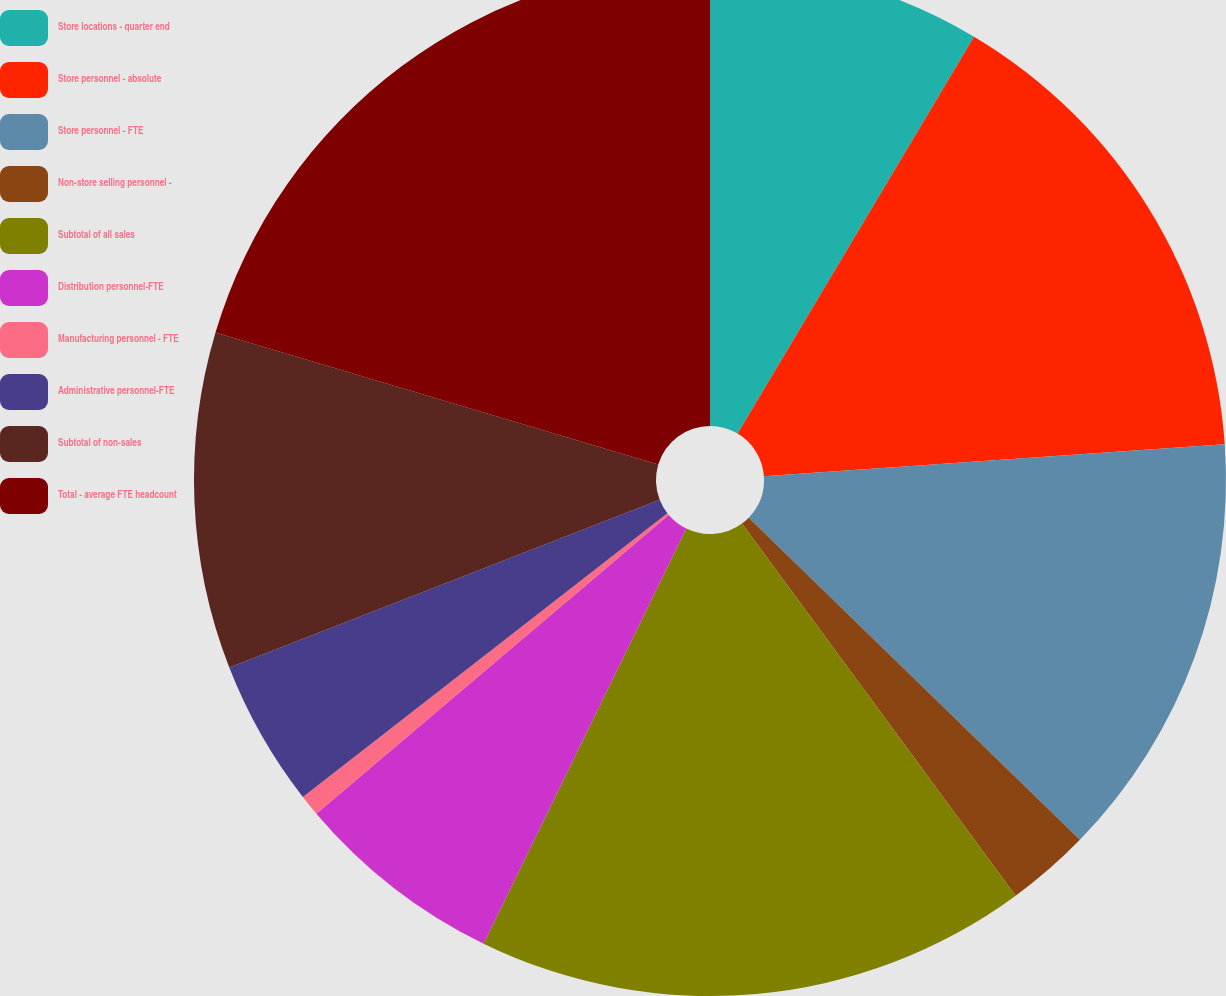<chart> <loc_0><loc_0><loc_500><loc_500><pie_chart><fcel>Store locations - quarter end<fcel>Store personnel - absolute<fcel>Store personnel - FTE<fcel>Non-store selling personnel -<fcel>Subtotal of all sales<fcel>Distribution personnel-FTE<fcel>Manufacturing personnel - FTE<fcel>Administrative personnel-FTE<fcel>Subtotal of non-sales<fcel>Total - average FTE headcount<nl><fcel>8.55%<fcel>15.35%<fcel>13.38%<fcel>2.63%<fcel>17.32%<fcel>6.58%<fcel>0.66%<fcel>4.61%<fcel>10.53%<fcel>20.39%<nl></chart> 